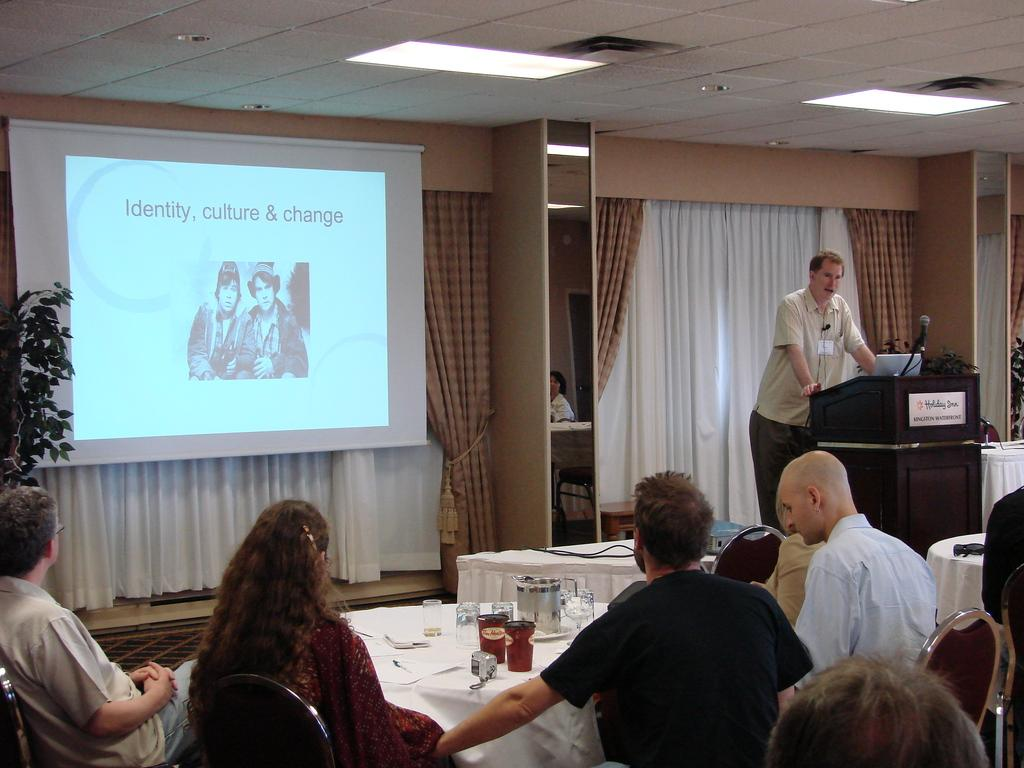<image>
Give a short and clear explanation of the subsequent image. A man is giving a presentation about identity, culture, and change. 